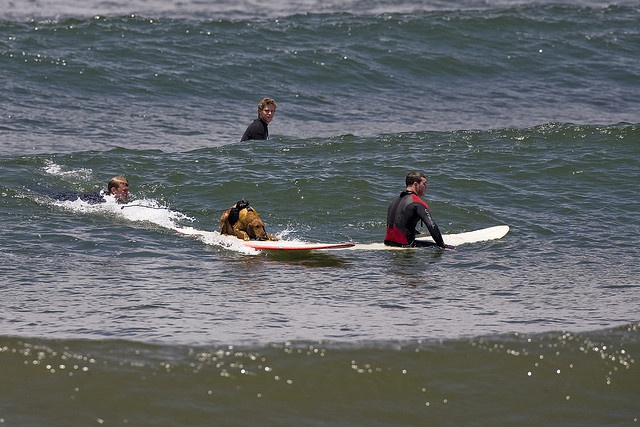Describe the objects in this image and their specific colors. I can see people in darkgray, black, maroon, gray, and brown tones, dog in darkgray, black, maroon, and brown tones, surfboard in darkgray, white, lightpink, maroon, and black tones, surfboard in darkgray, white, gray, and black tones, and people in darkgray, black, gray, and maroon tones in this image. 